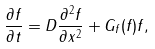<formula> <loc_0><loc_0><loc_500><loc_500>\frac { \partial f } { \partial t } = D \frac { \partial ^ { 2 } f } { \partial x ^ { 2 } } + G _ { f } ( f ) f ,</formula> 